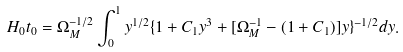Convert formula to latex. <formula><loc_0><loc_0><loc_500><loc_500>H _ { 0 } t _ { 0 } = \Omega _ { M } ^ { - 1 / 2 } \int _ { 0 } ^ { 1 } y ^ { 1 / 2 } \{ 1 + C _ { 1 } y ^ { 3 } + [ \Omega _ { M } ^ { - 1 } - ( 1 + C _ { 1 } ) ] y \} ^ { - 1 / 2 } d y .</formula> 